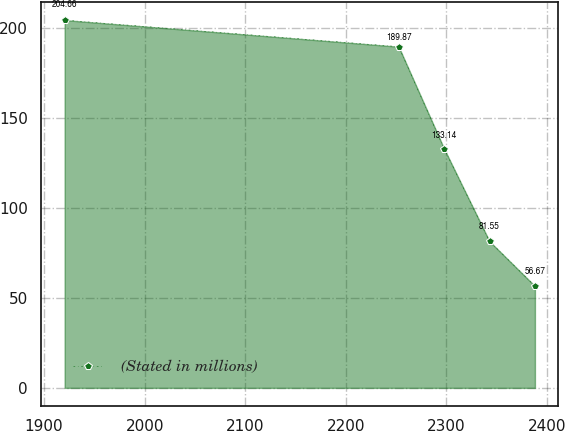Convert chart to OTSL. <chart><loc_0><loc_0><loc_500><loc_500><line_chart><ecel><fcel>(Stated in millions)<nl><fcel>1920.48<fcel>204.66<nl><fcel>2252.62<fcel>189.87<nl><fcel>2297.77<fcel>133.14<nl><fcel>2342.92<fcel>81.55<nl><fcel>2388.07<fcel>56.67<nl></chart> 